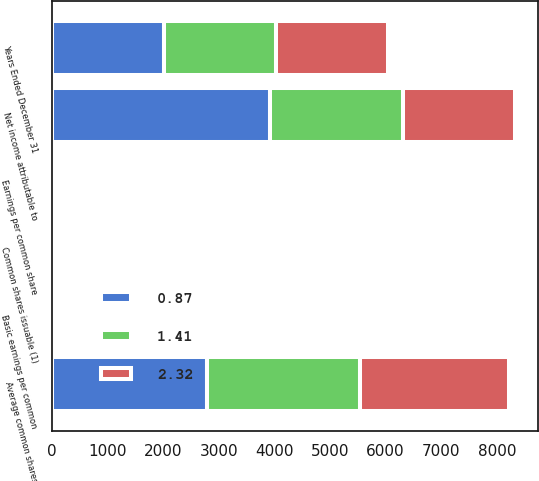<chart> <loc_0><loc_0><loc_500><loc_500><stacked_bar_chart><ecel><fcel>Years Ended December 31<fcel>Net income attributable to<fcel>Average common shares<fcel>Common shares issuable (1)<fcel>Basic earnings per common<fcel>Earnings per common share<nl><fcel>2.32<fcel>2018<fcel>2016.5<fcel>2679<fcel>15<fcel>2.34<fcel>2.32<nl><fcel>1.41<fcel>2017<fcel>2394<fcel>2748<fcel>18<fcel>0.88<fcel>0.87<nl><fcel>0.87<fcel>2016<fcel>3920<fcel>2787<fcel>21<fcel>1.42<fcel>1.41<nl></chart> 